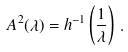Convert formula to latex. <formula><loc_0><loc_0><loc_500><loc_500>A ^ { 2 } ( \lambda ) = h ^ { - 1 } \left ( \frac { 1 } { \lambda } \right ) \, .</formula> 